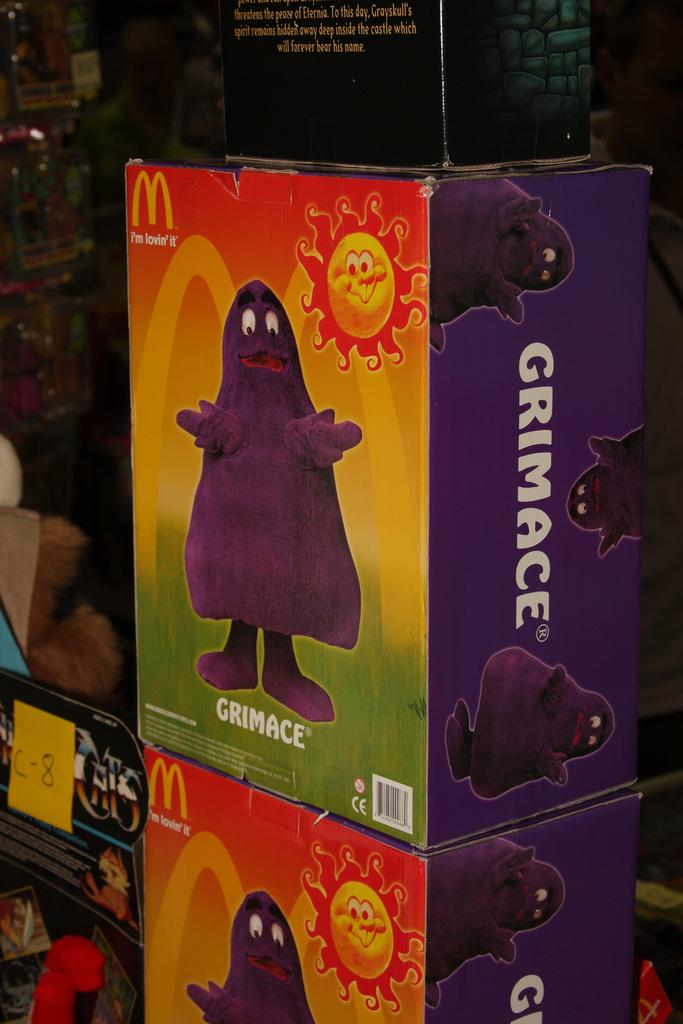<image>
Offer a succinct explanation of the picture presented. Boxes from McDonald's feature a drawing of a sunshine and Grimace under it. 